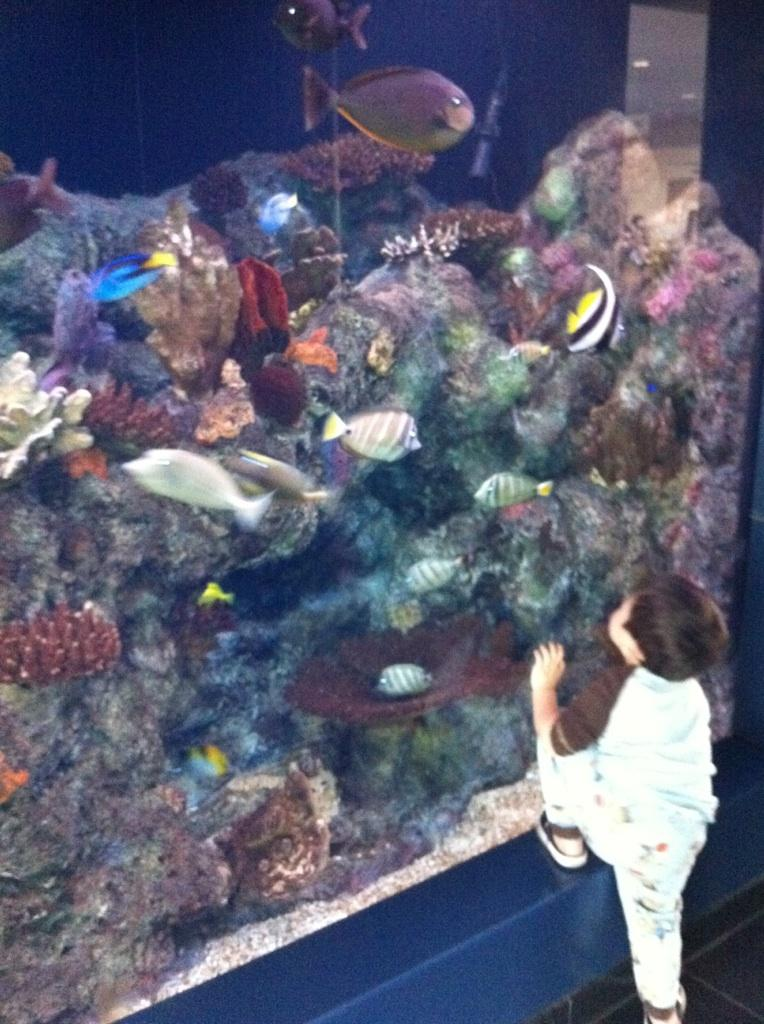What is the main subject of the image? The main subject of the image is a small boy. What is the boy wearing? The boy is wearing a white t-shirt. What is the boy's posture in the image? The boy is standing. What is the boy looking at in the image? The boy is looking at a big glass aquarium. What can be seen inside the aquarium? There are fishes and coral stones visible in the aquarium. What invention does the boy need to improve the aquarium's water quality? There is no mention of an invention or need for improvement in the image. The boy is simply looking at the aquarium with fishes and coral stones inside. 